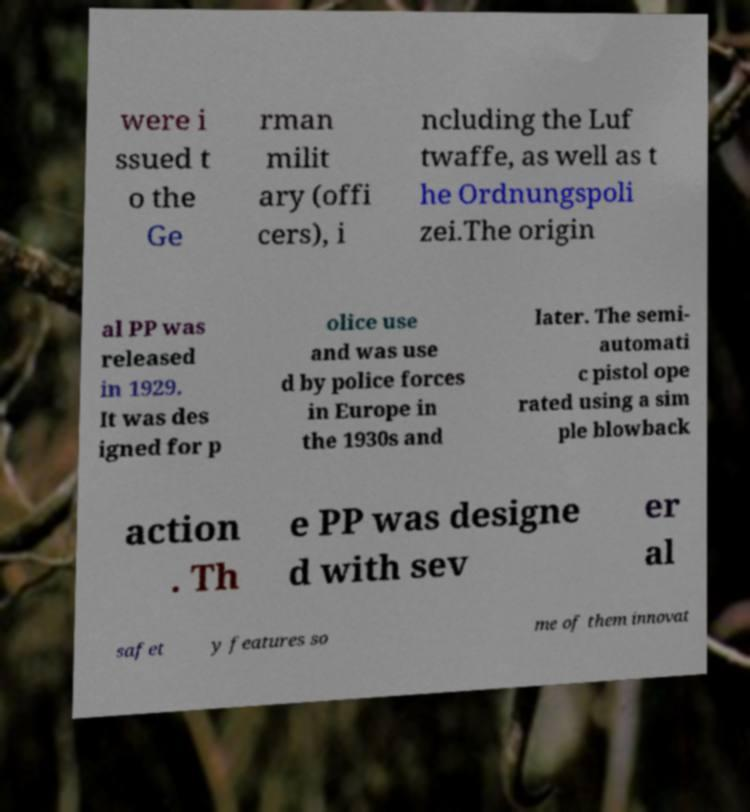I need the written content from this picture converted into text. Can you do that? were i ssued t o the Ge rman milit ary (offi cers), i ncluding the Luf twaffe, as well as t he Ordnungspoli zei.The origin al PP was released in 1929. It was des igned for p olice use and was use d by police forces in Europe in the 1930s and later. The semi- automati c pistol ope rated using a sim ple blowback action . Th e PP was designe d with sev er al safet y features so me of them innovat 